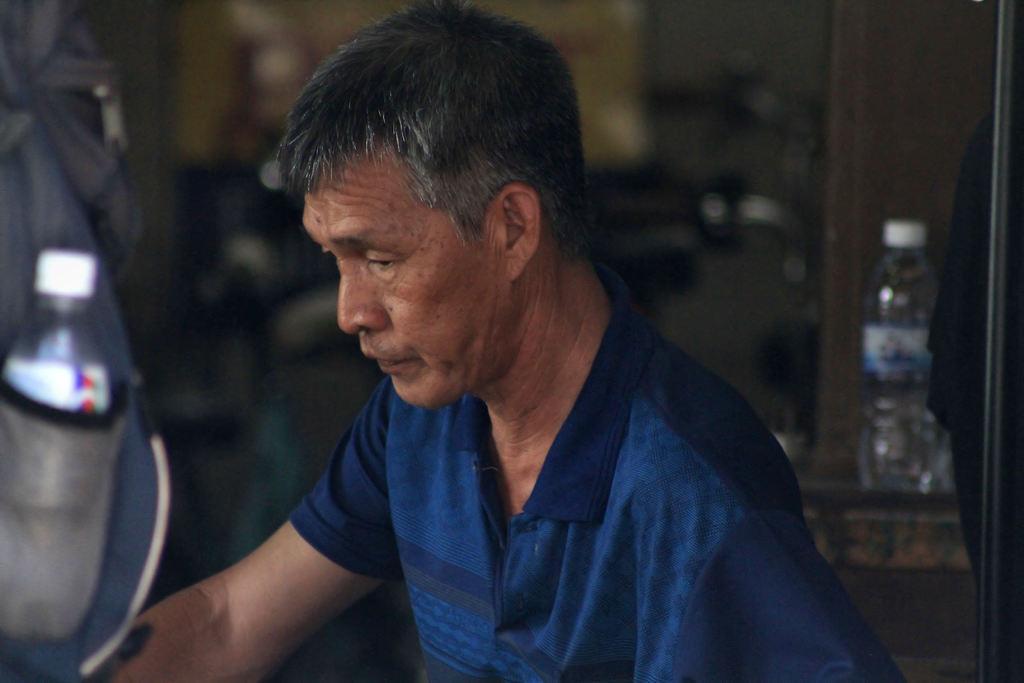Can you describe this image briefly? In this image we can see a man wearing t-shirt and there is an object which looks like a bag and in the background, we can see a water bottle and the image is blurred. 